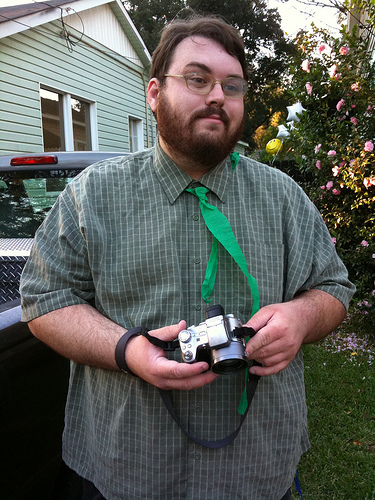What's the man holding? The man is holding a vintage film camera, based on its compact shape and vintage design. 